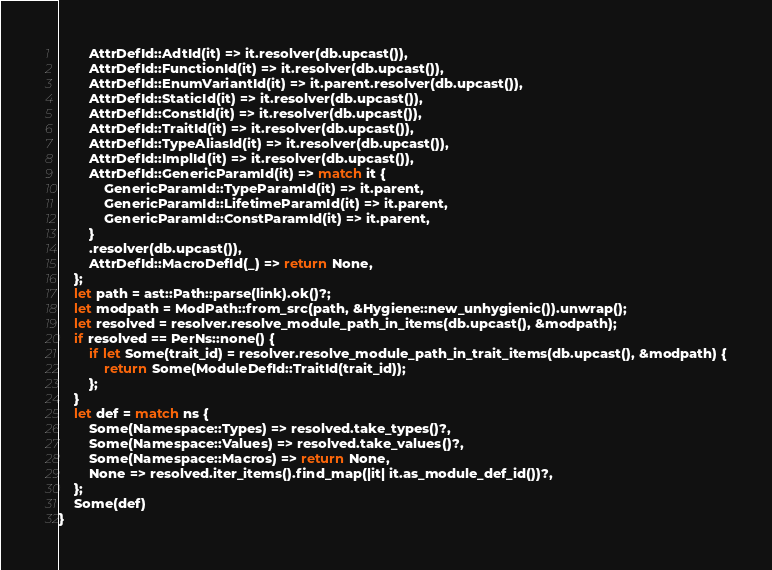<code> <loc_0><loc_0><loc_500><loc_500><_Rust_>        AttrDefId::AdtId(it) => it.resolver(db.upcast()),
        AttrDefId::FunctionId(it) => it.resolver(db.upcast()),
        AttrDefId::EnumVariantId(it) => it.parent.resolver(db.upcast()),
        AttrDefId::StaticId(it) => it.resolver(db.upcast()),
        AttrDefId::ConstId(it) => it.resolver(db.upcast()),
        AttrDefId::TraitId(it) => it.resolver(db.upcast()),
        AttrDefId::TypeAliasId(it) => it.resolver(db.upcast()),
        AttrDefId::ImplId(it) => it.resolver(db.upcast()),
        AttrDefId::GenericParamId(it) => match it {
            GenericParamId::TypeParamId(it) => it.parent,
            GenericParamId::LifetimeParamId(it) => it.parent,
            GenericParamId::ConstParamId(it) => it.parent,
        }
        .resolver(db.upcast()),
        AttrDefId::MacroDefId(_) => return None,
    };
    let path = ast::Path::parse(link).ok()?;
    let modpath = ModPath::from_src(path, &Hygiene::new_unhygienic()).unwrap();
    let resolved = resolver.resolve_module_path_in_items(db.upcast(), &modpath);
    if resolved == PerNs::none() {
        if let Some(trait_id) = resolver.resolve_module_path_in_trait_items(db.upcast(), &modpath) {
            return Some(ModuleDefId::TraitId(trait_id));
        };
    }
    let def = match ns {
        Some(Namespace::Types) => resolved.take_types()?,
        Some(Namespace::Values) => resolved.take_values()?,
        Some(Namespace::Macros) => return None,
        None => resolved.iter_items().find_map(|it| it.as_module_def_id())?,
    };
    Some(def)
}
</code> 